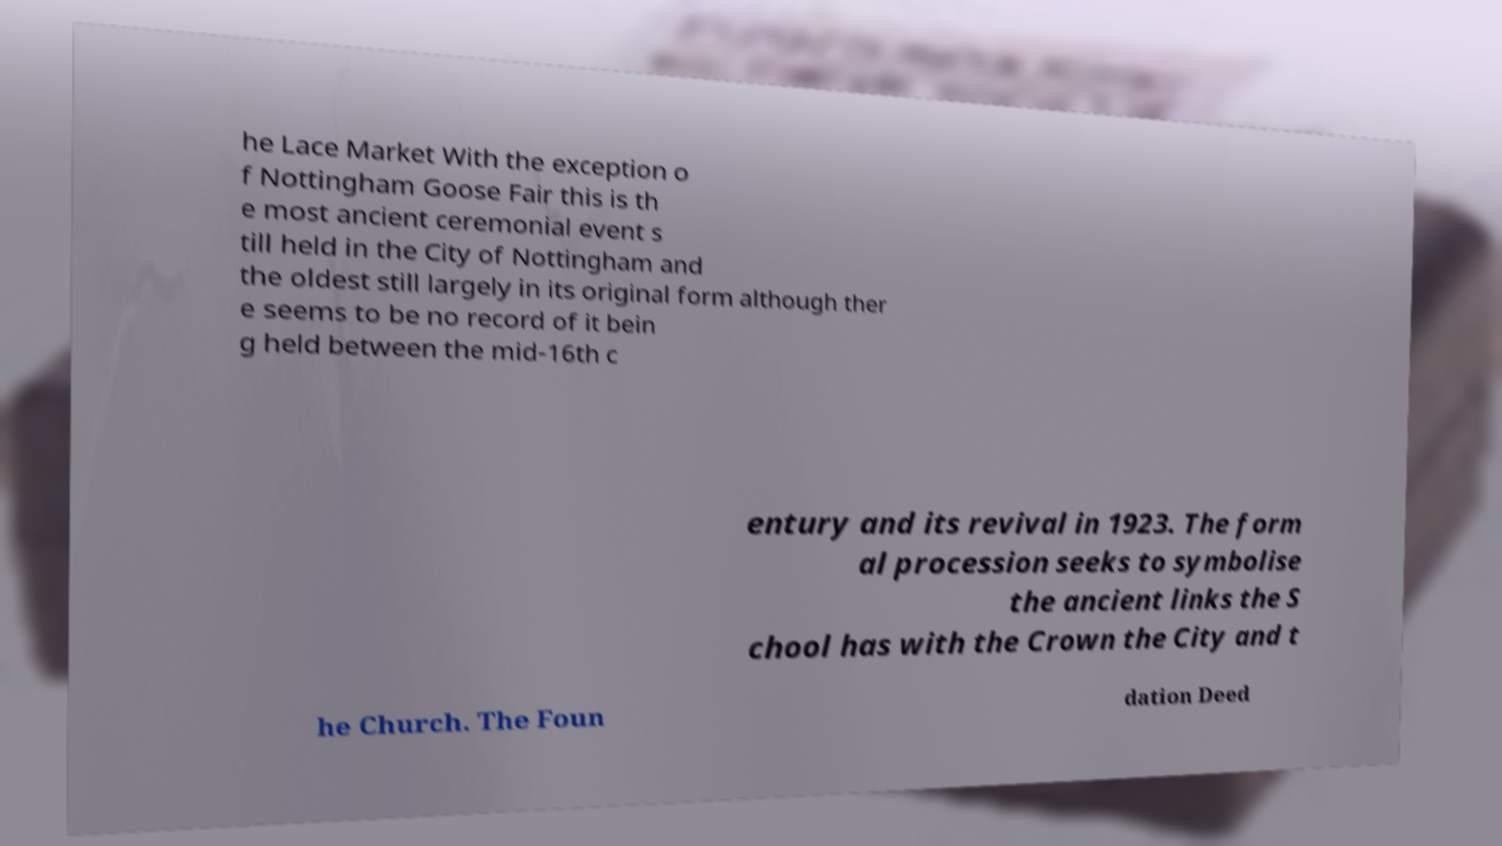I need the written content from this picture converted into text. Can you do that? he Lace Market With the exception o f Nottingham Goose Fair this is th e most ancient ceremonial event s till held in the City of Nottingham and the oldest still largely in its original form although ther e seems to be no record of it bein g held between the mid-16th c entury and its revival in 1923. The form al procession seeks to symbolise the ancient links the S chool has with the Crown the City and t he Church. The Foun dation Deed 